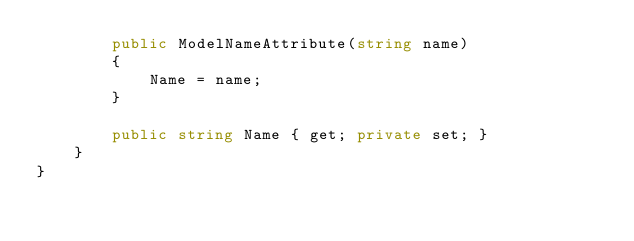<code> <loc_0><loc_0><loc_500><loc_500><_C#_>        public ModelNameAttribute(string name)
        {
            Name = name;
        }

        public string Name { get; private set; }
    }
}</code> 